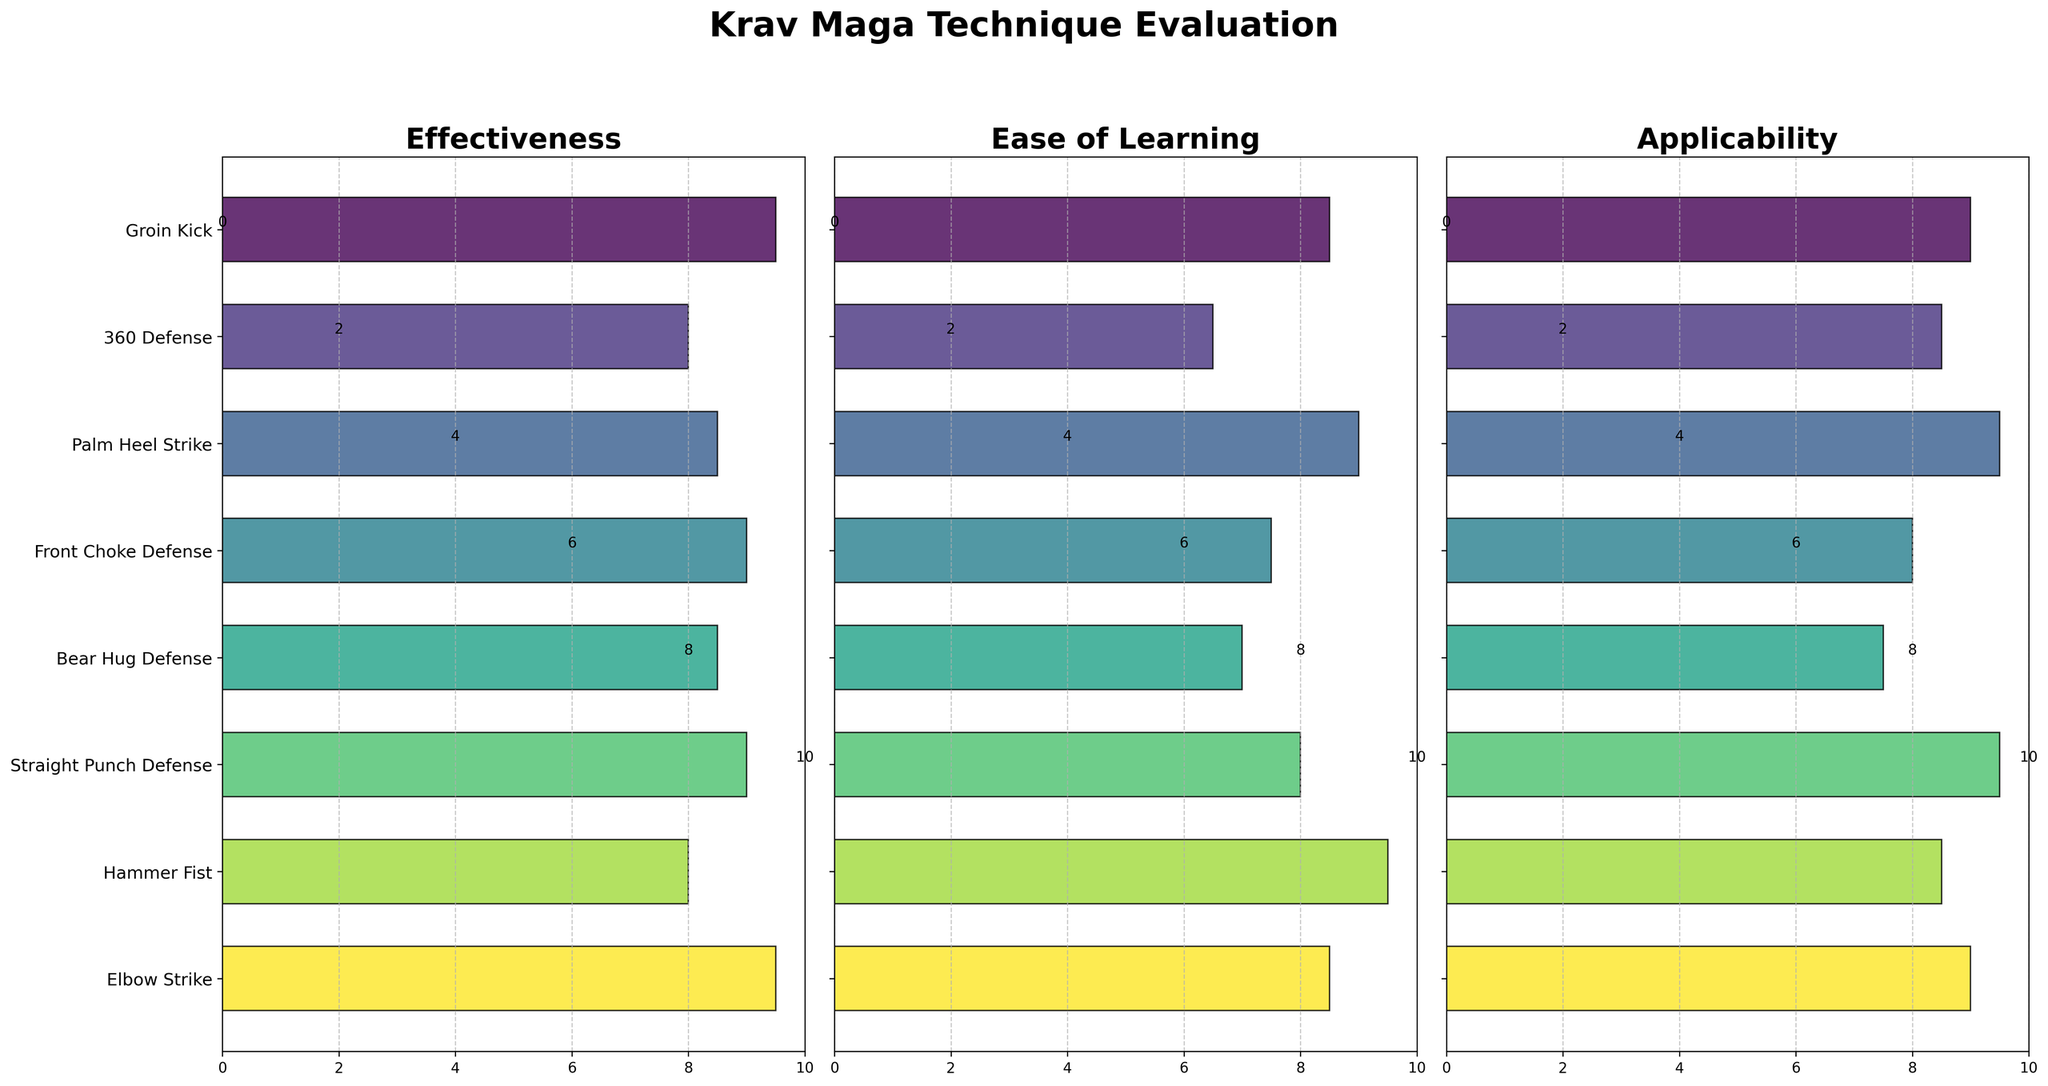What is the title of the entire figure? The title of the entire figure is usually displayed at the top. Looking at the rendered figure, the title is written clearly in bold and large font.
Answer: Krav Maga Technique Evaluation What are the three variables measured in the figure? The three variables are stated at the title of each horizontal subplot. They are Effectiveness, Ease of Learning, and Applicability.
Answer: Effectiveness, Ease of Learning, Applicability Which technique has the lowest Effectiveness rating? To determine the lowest Effectiveness rating, we look at the horizontal bars in the Effectiveness subplot and find the shortest one.
Answer: 360 Defense How many techniques have an Ease of Learning rating equal to or above 8? To find this, we count the number of techniques with bars reaching or exceeding the value of 8 in the Ease of Learning subplot. Techniques surpassing or meeting this threshold are Groin Kick, Palm Heel Strike, Straight Punch Defense, and Hammer Fist.
Answer: 4 Which technique scores highest in Applicability? This involves identifying the longest bar in the Applicability subplot. The longest bar is that of Palm Heel Strike and Straight Punch Defense.
Answer: Palm Heel Strike, Straight Punch Defense What is the average Effectiveness rating of Groin Kick and Elbow Strike? To calculate this, we find the ratings for both Groin Kick (9.5) and Elbow Strike (9.5) in the Effectiveness subplot, add them together (9.5 + 9.5 = 19), and divide by 2 (19 / 2).
Answer: 9.5 Which two techniques have equal Ease of Learning ratings? To find techniques with equal Ease of Learning ratings, we look for bars in the Ease of Learning subplot that reach the same point on the x-axis. Both the Groin Kick and Elbow Strike are rated at 8.5.
Answer: Groin Kick, Elbow Strike Did Palm Heel Strike receive high ratings in all three categories? We check the bars for Palm Heel Strike across all three subplots. Each subplot shows high ratings (8.5 in Effectiveness, 9.0 in Ease of Learning, 9.5 in Applicability), all above 8.
Answer: Yes Which technique has a higher Applicability rating: 360 Defense or Bear Hug Defense? To compare, we look at the bars for both techniques in the Applicability subplot. 360 Defense has a rating of 8.5, while Bear Hug Defense has a rating of 7.5.
Answer: 360 Defense 